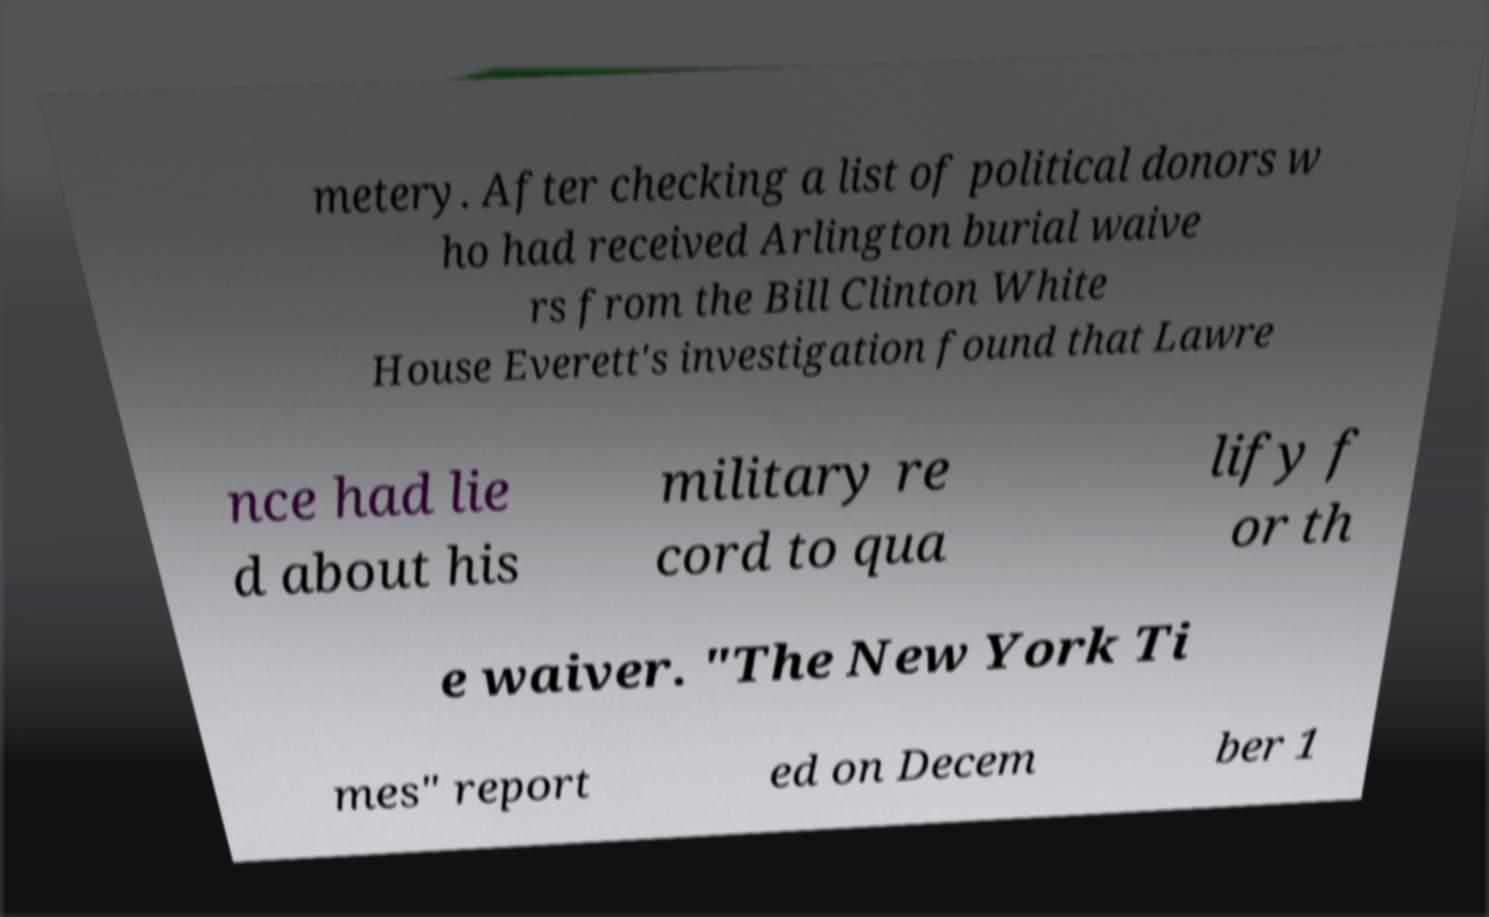Please identify and transcribe the text found in this image. metery. After checking a list of political donors w ho had received Arlington burial waive rs from the Bill Clinton White House Everett's investigation found that Lawre nce had lie d about his military re cord to qua lify f or th e waiver. "The New York Ti mes" report ed on Decem ber 1 